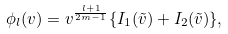<formula> <loc_0><loc_0><loc_500><loc_500>\phi _ { l } ( v ) = v ^ { \frac { l + 1 } { 2 m - 1 } } \{ I _ { 1 } ( \tilde { v } ) + I _ { 2 } ( \tilde { v } ) \} ,</formula> 